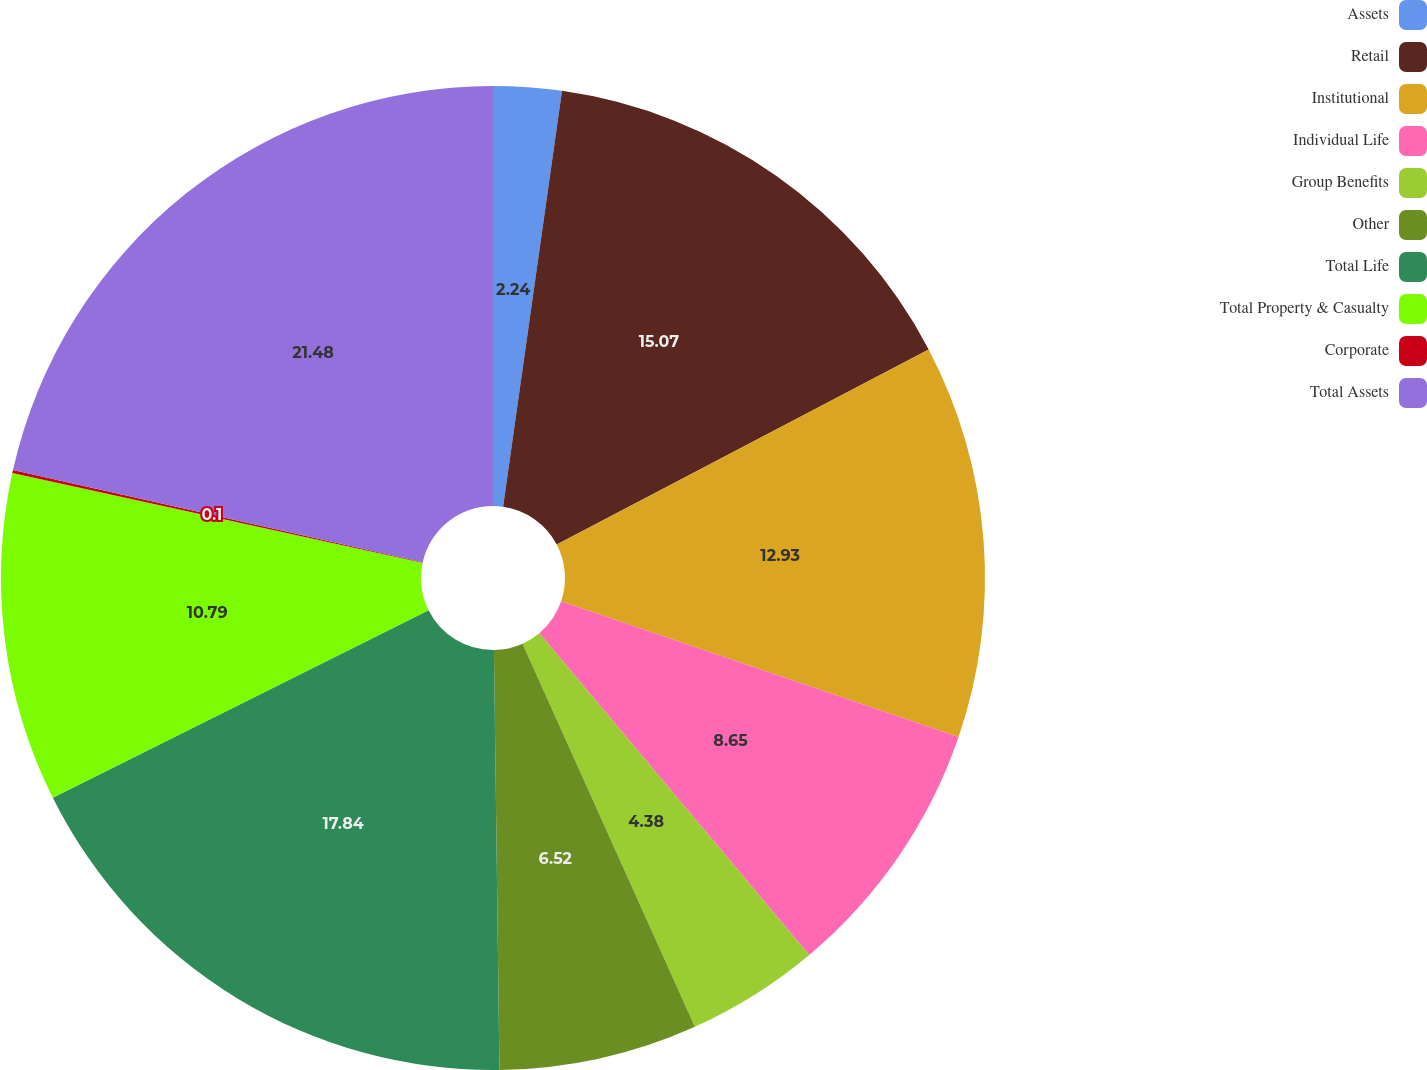<chart> <loc_0><loc_0><loc_500><loc_500><pie_chart><fcel>Assets<fcel>Retail<fcel>Institutional<fcel>Individual Life<fcel>Group Benefits<fcel>Other<fcel>Total Life<fcel>Total Property & Casualty<fcel>Corporate<fcel>Total Assets<nl><fcel>2.24%<fcel>15.07%<fcel>12.93%<fcel>8.65%<fcel>4.38%<fcel>6.52%<fcel>17.84%<fcel>10.79%<fcel>0.1%<fcel>21.48%<nl></chart> 